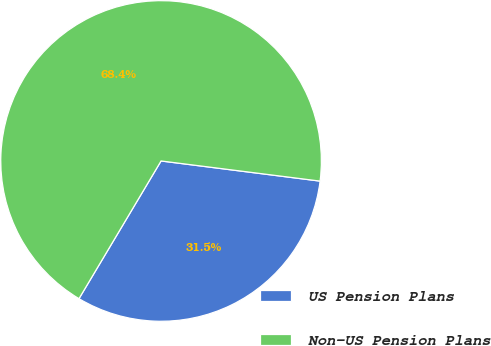<chart> <loc_0><loc_0><loc_500><loc_500><pie_chart><fcel>US Pension Plans<fcel>Non-US Pension Plans<nl><fcel>31.55%<fcel>68.45%<nl></chart> 